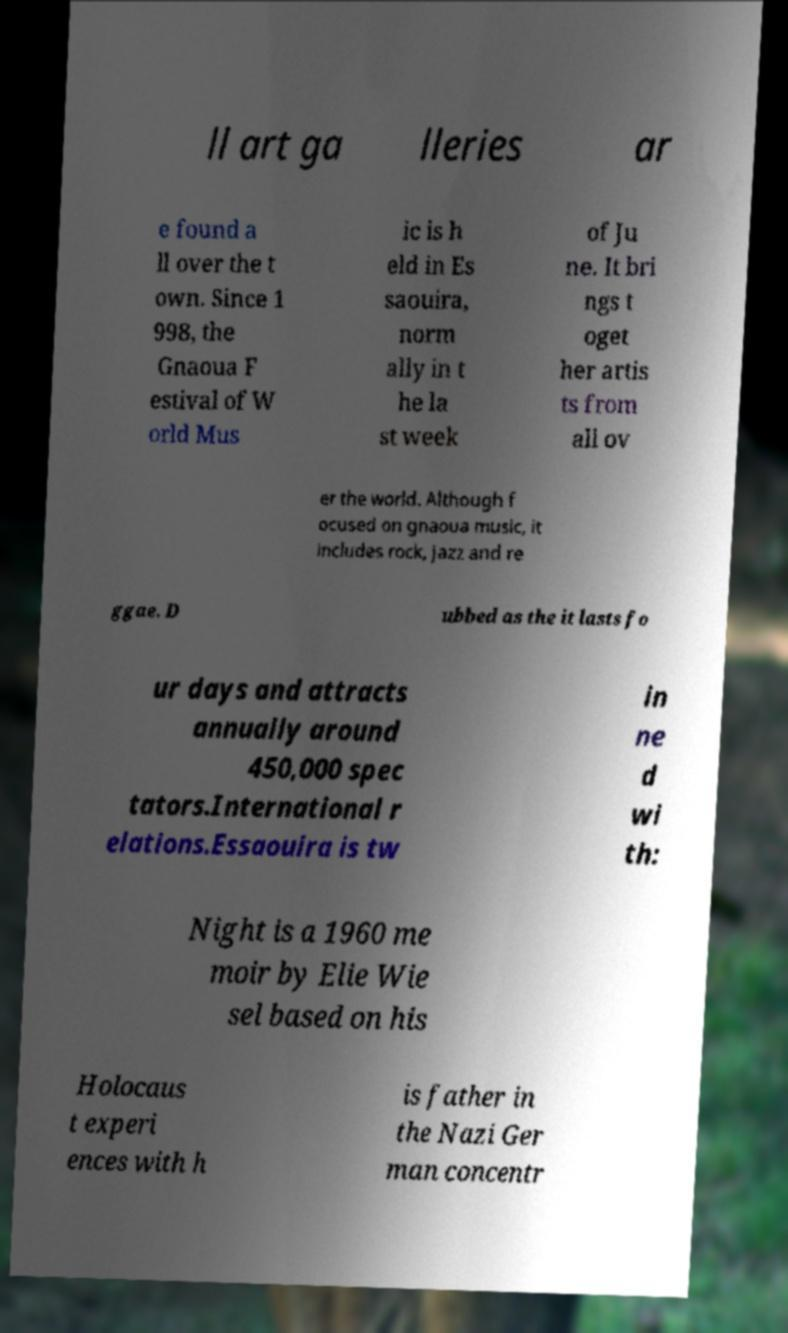For documentation purposes, I need the text within this image transcribed. Could you provide that? ll art ga lleries ar e found a ll over the t own. Since 1 998, the Gnaoua F estival of W orld Mus ic is h eld in Es saouira, norm ally in t he la st week of Ju ne. It bri ngs t oget her artis ts from all ov er the world. Although f ocused on gnaoua music, it includes rock, jazz and re ggae. D ubbed as the it lasts fo ur days and attracts annually around 450,000 spec tators.International r elations.Essaouira is tw in ne d wi th: Night is a 1960 me moir by Elie Wie sel based on his Holocaus t experi ences with h is father in the Nazi Ger man concentr 